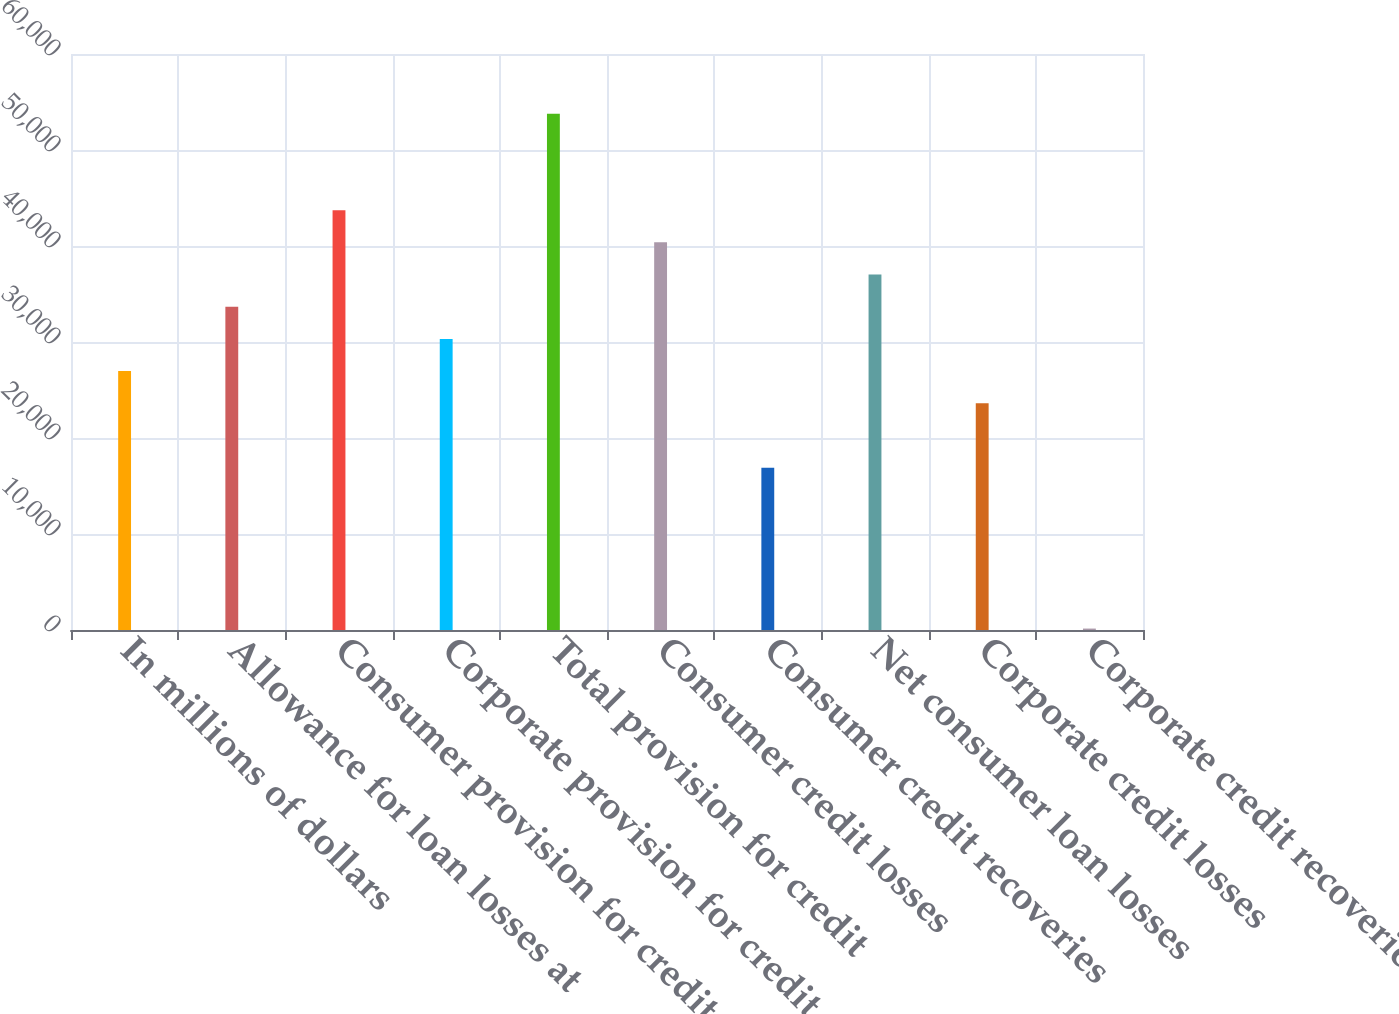Convert chart to OTSL. <chart><loc_0><loc_0><loc_500><loc_500><bar_chart><fcel>In millions of dollars<fcel>Allowance for loan losses at<fcel>Consumer provision for credit<fcel>Corporate provision for credit<fcel>Total provision for credit<fcel>Consumer credit losses<fcel>Consumer credit recoveries<fcel>Net consumer loan losses<fcel>Corporate credit losses<fcel>Corporate credit recoveries<nl><fcel>26969<fcel>33674<fcel>43731.5<fcel>30321.5<fcel>53789<fcel>40379<fcel>16911.5<fcel>37026.5<fcel>23616.5<fcel>149<nl></chart> 